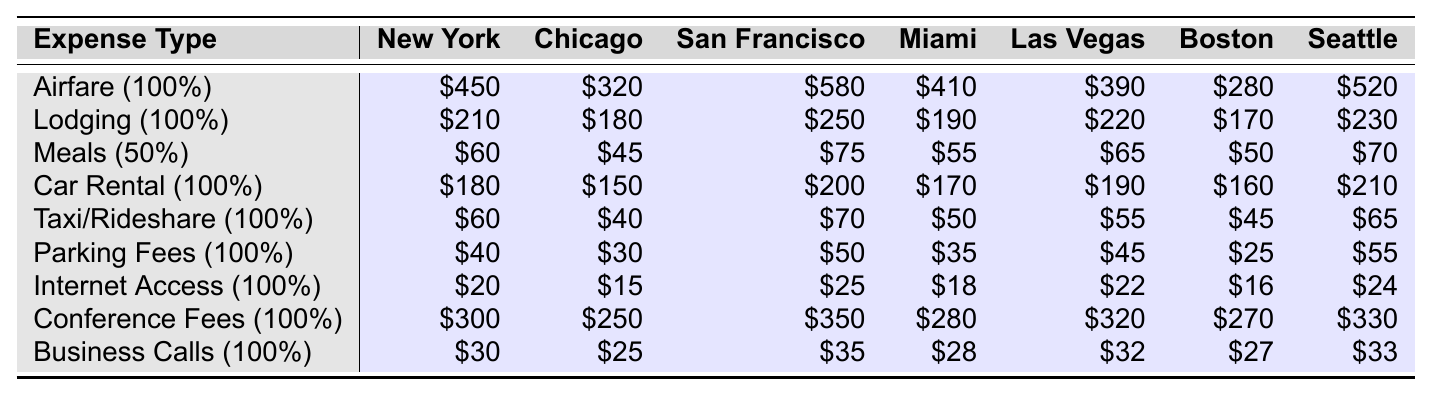What is the total airfare expense for all destinations? To find the total airfare expense, we sum up the airfare amounts: 450 + 320 + 580 + 410 + 390 + 280 + 520 = 2950.
Answer: 2950 What percentage of meal expenses is tax-deductible? The table indicates that meal expenses have a tax-deductible percentage of 50%.
Answer: 50% Which city has the highest car rental expense? Looking at the car rental expenses, San Francisco has the highest amount of $200.
Answer: San Francisco What is the average lodging expense across all destinations? Add the lodging amounts: 210 + 180 + 250 + 190 + 220 + 170 + 230 = 1450. There are 7 destinations, so the average is 1450/7 = approximately 207.14.
Answer: 207.14 Is internet access expense fully deductible? The table shows that internet access expense has a deductible percentage of 100%.
Answer: Yes Which destination has the lowest parking fee? By scanning the parking fee amounts, Chicago has the lowest parking fee at $30.
Answer: Chicago What is the total business calls expense across all cities? Summing up the business call amounts: 30 + 25 + 35 + 28 + 32 + 27 + 33 = 210.
Answer: 210 Which city has the highest lodging expense? By reviewing the lodging expenses, New York has the highest lodging expense of $210.
Answer: New York What is the sum of all deductible expenses for meals? Meals have a tax-deductible portion of 50%. To find the deductible amount, first calculate the total meal expenses: 60 + 45 + 75 + 55 + 65 + 50 + 70 = 450. Then, take 50% of 450, which is 225.
Answer: 225 Which city has the highest total expense for conference fees? San Francisco has the highest expense for conference fees at $350, compared to others in the table.
Answer: San Francisco What is the total deductible amount for lodging in Miami? The lodging expense in Miami is $190 and since the deductible percentage is 100%, the total deductible amount is 190 * 100% = $190.
Answer: 190 What is the total deductible amount for meals across all destinations? The total meal expenses are 60 + 45 + 75 + 55 + 65 + 50 + 70 = 450. With a deductible percentage of 50%, the total deductible amount is 450 * 50% = 225.
Answer: 225 